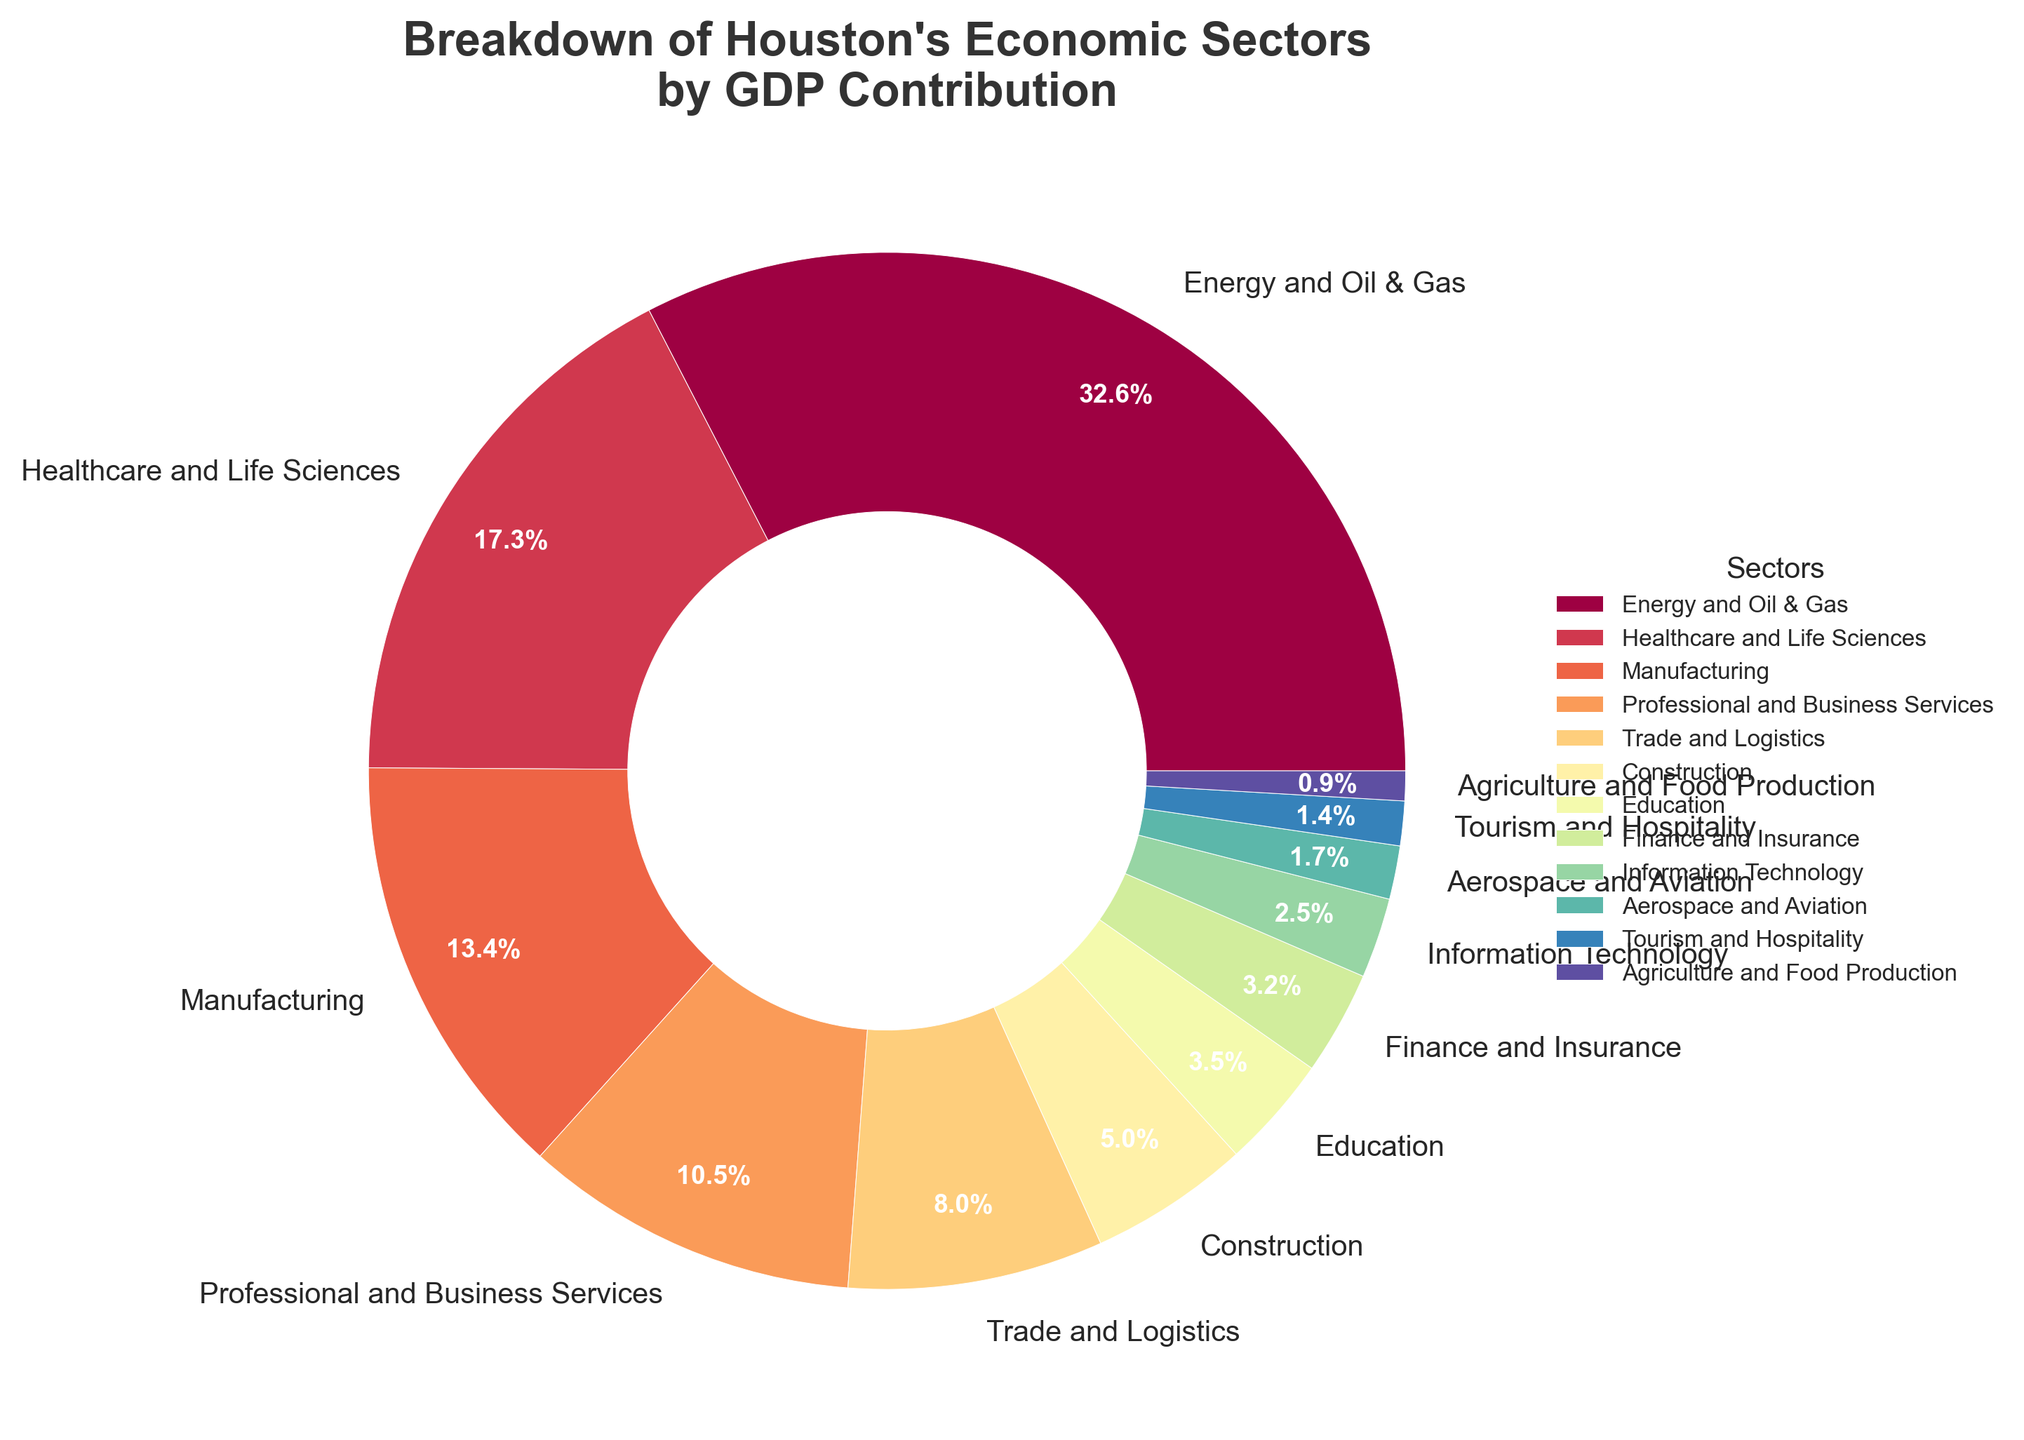What sector contributes the most to Houston's GDP? The pie chart shows various economic sectors' contributions to Houston's GDP with percentage labels. The largest sector is highlighted by the largest slice.
Answer: Energy and Oil & Gas Which two sectors combined contribute the most to Houston's GDP? To find this, we identify the two largest sectors from the pie chart and sum their contributions: Energy and Oil & Gas (35.2%) and Healthcare and Life Sciences (18.7%).
Answer: Energy and Oil & Gas and Healthcare and Life Sciences How much more does Manufacturing contribute to Houston's GDP compared to Construction? By comparing the percentages for Manufacturing (14.5%) and Construction (5.4%) in the pie chart: 14.5% - 5.4% = 9.1%.
Answer: 9.1% Which sector contributes the least to Houston's GDP? The pie chart's smallest slice represents the sector with the smallest contribution percentage.
Answer: Agriculture and Food Production What is the combined GDP contribution of the sectors contributing less than 5% each? Add the contributions of sectors under 5%: Construction (5.4%), Education (3.8%), Finance and Insurance (3.5%), Information Technology (2.7%), Aerospace and Aviation (1.8%), Tourism and Hospitality (1.5%), Agriculture and Food Production (1.0%). Total = 19.7%.
Answer: 19.7% Are there more sectors contributing above 10% or below 5% to Houston's GDP? Count the sectors contributing above 10% (Energy and Oil & Gas, Healthcare and Life Sciences, Manufacturing, Professional and Business Services) and below 5% from the pie chart. There are 4 sectors above 10% and 6 sectors below 5%.
Answer: Below 5% What is the difference between the GDP contributions of the highest and lowest contributing sectors? Subtract the smallest sector's contribution (Agriculture and Food Production - 1.0%) from the largest sector's contribution (Energy and Oil & Gas - 35.2%): 35.2% - 1.0% = 34.2%.
Answer: 34.2% What percentage of Houston's GDP is contributed by service-oriented sectors? Sum the contributions of service-oriented sectors: Healthcare and Life Sciences (18.7%), Professional and Business Services (11.3%), Trade and Logistics (8.6%), Education (3.8%), Finance and Insurance (3.5%), Information Technology (2.7%), Tourism and Hospitality (1.5%): Total = 50.1%.
Answer: 50.1% 